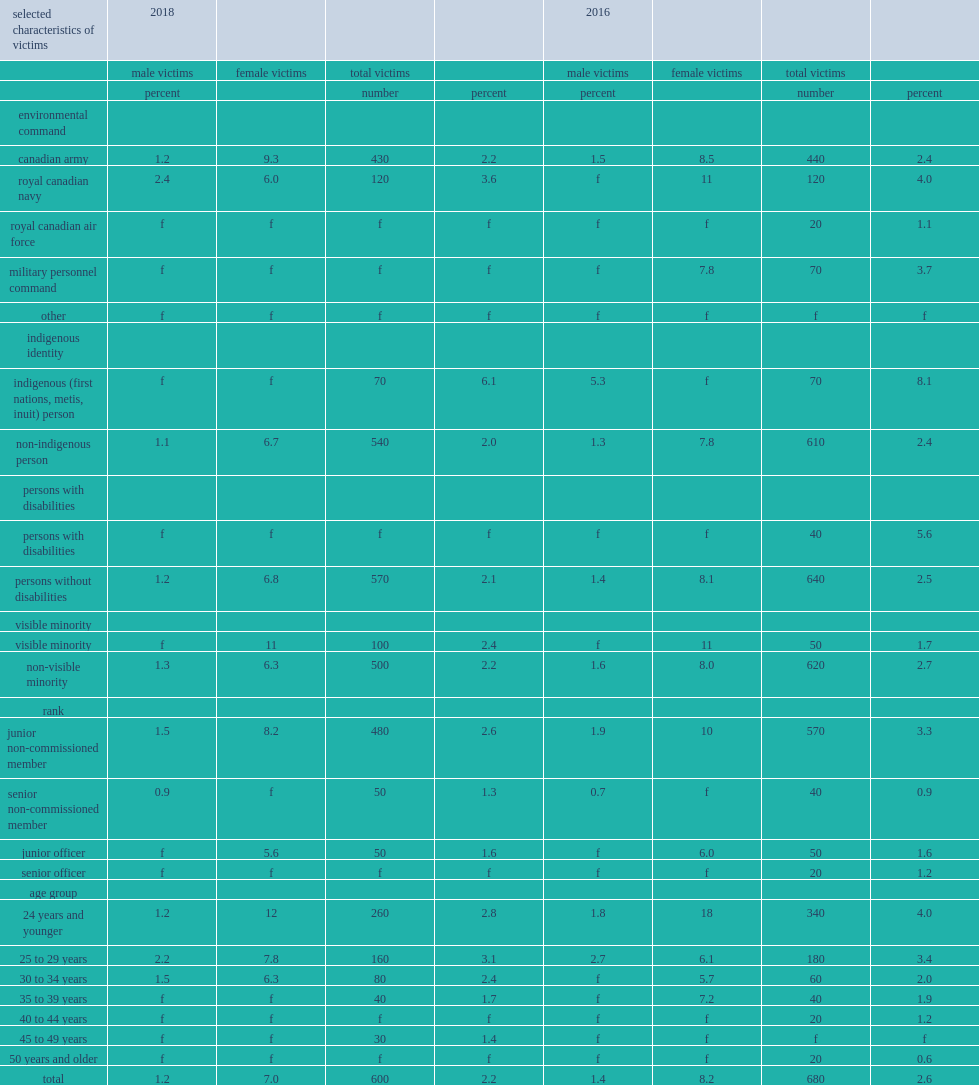Which kind of reservists were at higher risk for sexual assault in 2018, aged 24 and younger or those aged 25 to 29? 24 years and younger. What percentage of reservists aged 24 and younger were at risk for sexual assault in 2018? 2.8. What percentage of reservists aged 25 to 29 were at risk for sexual assault in 2018? 3.1. When was the prevalence of sexual assault lower among reservists, in 2016 or in 2018? 2016.0. What was the prevalence of sexual assault among reservists aged 24 and younger in 2016? 4.0. What was the prevalence of sexual assault among reservists aged 24 and younger in 2018? 2.8. Which reported a higher prevalence, senior non-commissioned members or junior non-commissioned members? Junior non-commissioned member. Which reported a higher prevalence, junior officers or junior non-commissioned members? Junior non-commissioned member. When did junior non-commissioned members experience a lower prevalence of sexual assault, in 2016 or in 2018? 2018.0. Which kind of members were at a higher risk of sexual assault in 2018, who identified as indigenous or their non-indigenous counterparts? Indigenous (first nations, metis, inuit) person. In 2018, what percentage of members who identified as indigenous reported having been sexually assaulted? 6.1. How many times higher was the proportion of members who identified as indigenous than that reported by non-indigenous members in 2018? 3.05. When was it lower among non-visible minority women, in 2016 or in 2018? 2018.0. What percentage of non-visible minority women reported in 2016? 8.0. What percentage of non-visible minority women reported in 2018? 6.3. Where did reservists reported a higher overall prevalence of sexual assault in 2018, in the royal canadian navy or in the canadian army? Royal canadian navy. What kind of female reservists reported a higher prevalence in 2016, female naval reservists or female army reservists? Royal canadian navy. When was the prevalence of sexual assault among women in the naval reserves lower, in 2016 or in 2018? 2018.0. 